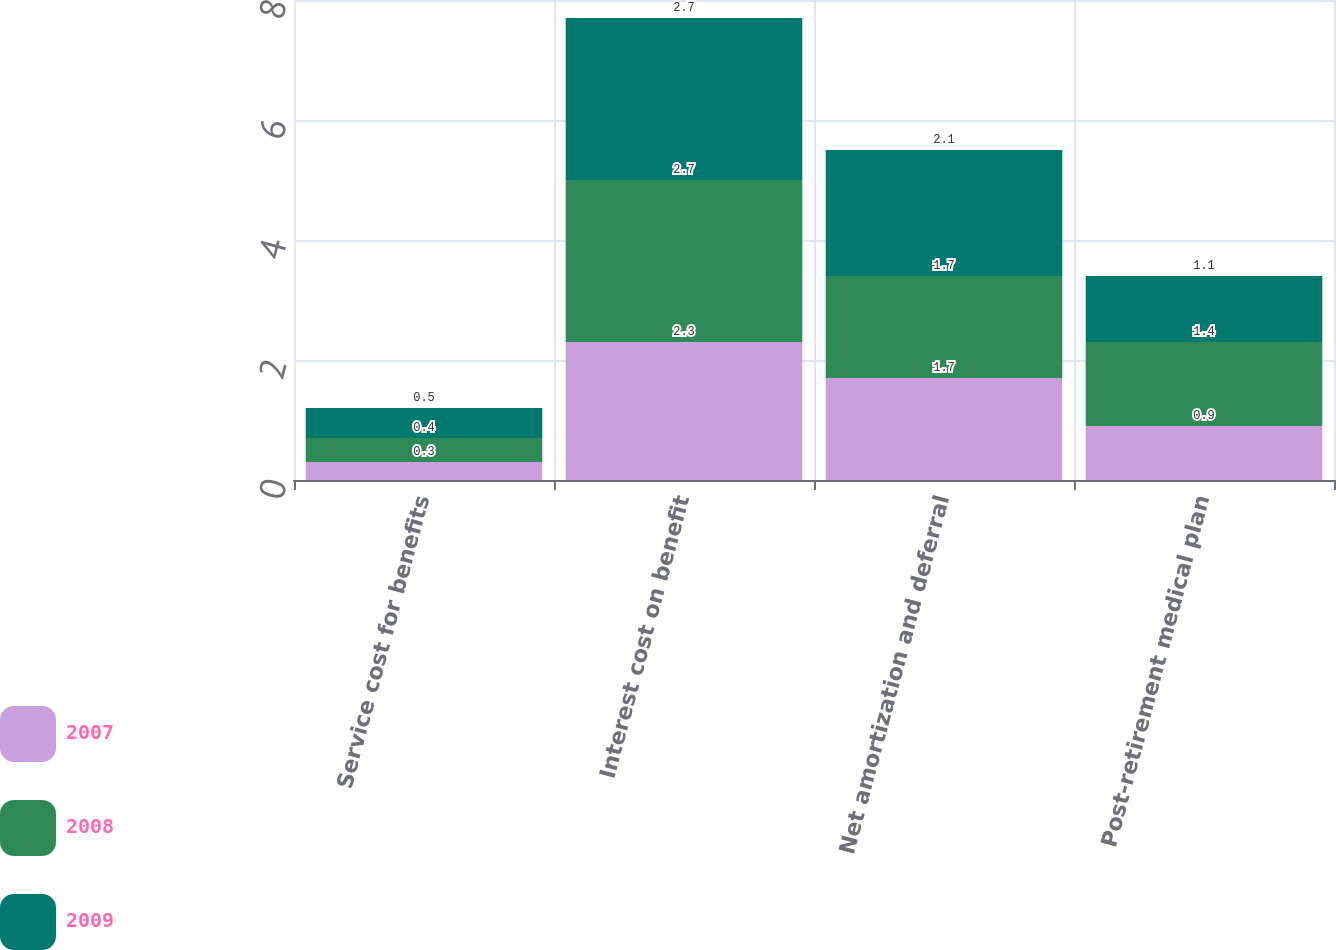Convert chart. <chart><loc_0><loc_0><loc_500><loc_500><stacked_bar_chart><ecel><fcel>Service cost for benefits<fcel>Interest cost on benefit<fcel>Net amortization and deferral<fcel>Post-retirement medical plan<nl><fcel>2007<fcel>0.3<fcel>2.3<fcel>1.7<fcel>0.9<nl><fcel>2008<fcel>0.4<fcel>2.7<fcel>1.7<fcel>1.4<nl><fcel>2009<fcel>0.5<fcel>2.7<fcel>2.1<fcel>1.1<nl></chart> 